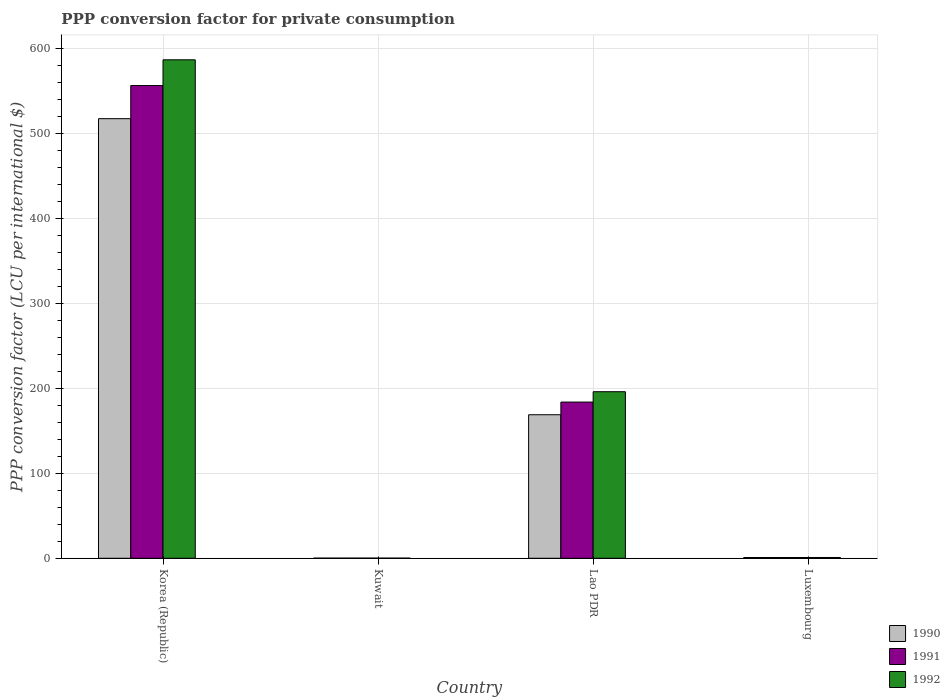How many groups of bars are there?
Your answer should be compact. 4. Are the number of bars per tick equal to the number of legend labels?
Offer a very short reply. Yes. Are the number of bars on each tick of the X-axis equal?
Make the answer very short. Yes. How many bars are there on the 1st tick from the left?
Your answer should be very brief. 3. How many bars are there on the 3rd tick from the right?
Offer a terse response. 3. What is the label of the 2nd group of bars from the left?
Give a very brief answer. Kuwait. In how many cases, is the number of bars for a given country not equal to the number of legend labels?
Offer a terse response. 0. What is the PPP conversion factor for private consumption in 1990 in Kuwait?
Your answer should be very brief. 0.17. Across all countries, what is the maximum PPP conversion factor for private consumption in 1991?
Offer a terse response. 556.12. Across all countries, what is the minimum PPP conversion factor for private consumption in 1991?
Keep it short and to the point. 0.17. In which country was the PPP conversion factor for private consumption in 1990 minimum?
Offer a terse response. Kuwait. What is the total PPP conversion factor for private consumption in 1990 in the graph?
Your response must be concise. 687.06. What is the difference between the PPP conversion factor for private consumption in 1992 in Lao PDR and that in Luxembourg?
Ensure brevity in your answer.  195.03. What is the difference between the PPP conversion factor for private consumption in 1990 in Lao PDR and the PPP conversion factor for private consumption in 1991 in Kuwait?
Offer a very short reply. 168.67. What is the average PPP conversion factor for private consumption in 1991 per country?
Keep it short and to the point. 185.24. What is the difference between the PPP conversion factor for private consumption of/in 1992 and PPP conversion factor for private consumption of/in 1990 in Luxembourg?
Provide a succinct answer. 0.01. In how many countries, is the PPP conversion factor for private consumption in 1991 greater than 580 LCU?
Your response must be concise. 0. What is the ratio of the PPP conversion factor for private consumption in 1991 in Korea (Republic) to that in Lao PDR?
Make the answer very short. 3.03. Is the PPP conversion factor for private consumption in 1991 in Lao PDR less than that in Luxembourg?
Ensure brevity in your answer.  No. Is the difference between the PPP conversion factor for private consumption in 1992 in Kuwait and Lao PDR greater than the difference between the PPP conversion factor for private consumption in 1990 in Kuwait and Lao PDR?
Your answer should be very brief. No. What is the difference between the highest and the second highest PPP conversion factor for private consumption in 1990?
Provide a short and direct response. 167.94. What is the difference between the highest and the lowest PPP conversion factor for private consumption in 1990?
Offer a terse response. 516.98. In how many countries, is the PPP conversion factor for private consumption in 1992 greater than the average PPP conversion factor for private consumption in 1992 taken over all countries?
Provide a succinct answer. 2. What does the 2nd bar from the left in Luxembourg represents?
Provide a succinct answer. 1991. Is it the case that in every country, the sum of the PPP conversion factor for private consumption in 1991 and PPP conversion factor for private consumption in 1990 is greater than the PPP conversion factor for private consumption in 1992?
Offer a terse response. Yes. What is the difference between two consecutive major ticks on the Y-axis?
Your response must be concise. 100. Does the graph contain any zero values?
Give a very brief answer. No. Where does the legend appear in the graph?
Offer a terse response. Bottom right. How are the legend labels stacked?
Provide a succinct answer. Vertical. What is the title of the graph?
Give a very brief answer. PPP conversion factor for private consumption. Does "1978" appear as one of the legend labels in the graph?
Ensure brevity in your answer.  No. What is the label or title of the X-axis?
Ensure brevity in your answer.  Country. What is the label or title of the Y-axis?
Keep it short and to the point. PPP conversion factor (LCU per international $). What is the PPP conversion factor (LCU per international $) of 1990 in Korea (Republic)?
Ensure brevity in your answer.  517.14. What is the PPP conversion factor (LCU per international $) in 1991 in Korea (Republic)?
Keep it short and to the point. 556.12. What is the PPP conversion factor (LCU per international $) of 1992 in Korea (Republic)?
Your answer should be compact. 586.41. What is the PPP conversion factor (LCU per international $) of 1990 in Kuwait?
Provide a succinct answer. 0.17. What is the PPP conversion factor (LCU per international $) of 1991 in Kuwait?
Give a very brief answer. 0.17. What is the PPP conversion factor (LCU per international $) in 1992 in Kuwait?
Your answer should be very brief. 0.17. What is the PPP conversion factor (LCU per international $) of 1990 in Lao PDR?
Give a very brief answer. 168.84. What is the PPP conversion factor (LCU per international $) of 1991 in Lao PDR?
Your response must be concise. 183.76. What is the PPP conversion factor (LCU per international $) in 1992 in Lao PDR?
Your answer should be very brief. 195.95. What is the PPP conversion factor (LCU per international $) in 1990 in Luxembourg?
Keep it short and to the point. 0.9. What is the PPP conversion factor (LCU per international $) in 1991 in Luxembourg?
Give a very brief answer. 0.91. What is the PPP conversion factor (LCU per international $) in 1992 in Luxembourg?
Your response must be concise. 0.92. Across all countries, what is the maximum PPP conversion factor (LCU per international $) of 1990?
Provide a succinct answer. 517.14. Across all countries, what is the maximum PPP conversion factor (LCU per international $) in 1991?
Offer a very short reply. 556.12. Across all countries, what is the maximum PPP conversion factor (LCU per international $) in 1992?
Provide a succinct answer. 586.41. Across all countries, what is the minimum PPP conversion factor (LCU per international $) of 1990?
Make the answer very short. 0.17. Across all countries, what is the minimum PPP conversion factor (LCU per international $) of 1991?
Your answer should be very brief. 0.17. Across all countries, what is the minimum PPP conversion factor (LCU per international $) of 1992?
Offer a terse response. 0.17. What is the total PPP conversion factor (LCU per international $) of 1990 in the graph?
Offer a terse response. 687.06. What is the total PPP conversion factor (LCU per international $) of 1991 in the graph?
Provide a succinct answer. 740.95. What is the total PPP conversion factor (LCU per international $) of 1992 in the graph?
Give a very brief answer. 783.45. What is the difference between the PPP conversion factor (LCU per international $) in 1990 in Korea (Republic) and that in Kuwait?
Provide a succinct answer. 516.98. What is the difference between the PPP conversion factor (LCU per international $) of 1991 in Korea (Republic) and that in Kuwait?
Provide a short and direct response. 555.94. What is the difference between the PPP conversion factor (LCU per international $) in 1992 in Korea (Republic) and that in Kuwait?
Provide a succinct answer. 586.24. What is the difference between the PPP conversion factor (LCU per international $) in 1990 in Korea (Republic) and that in Lao PDR?
Your answer should be compact. 348.3. What is the difference between the PPP conversion factor (LCU per international $) in 1991 in Korea (Republic) and that in Lao PDR?
Your answer should be very brief. 372.36. What is the difference between the PPP conversion factor (LCU per international $) in 1992 in Korea (Republic) and that in Lao PDR?
Offer a very short reply. 390.46. What is the difference between the PPP conversion factor (LCU per international $) of 1990 in Korea (Republic) and that in Luxembourg?
Your answer should be compact. 516.24. What is the difference between the PPP conversion factor (LCU per international $) of 1991 in Korea (Republic) and that in Luxembourg?
Your answer should be compact. 555.21. What is the difference between the PPP conversion factor (LCU per international $) in 1992 in Korea (Republic) and that in Luxembourg?
Ensure brevity in your answer.  585.49. What is the difference between the PPP conversion factor (LCU per international $) in 1990 in Kuwait and that in Lao PDR?
Provide a short and direct response. -168.68. What is the difference between the PPP conversion factor (LCU per international $) in 1991 in Kuwait and that in Lao PDR?
Your answer should be compact. -183.58. What is the difference between the PPP conversion factor (LCU per international $) in 1992 in Kuwait and that in Lao PDR?
Provide a short and direct response. -195.78. What is the difference between the PPP conversion factor (LCU per international $) in 1990 in Kuwait and that in Luxembourg?
Make the answer very short. -0.74. What is the difference between the PPP conversion factor (LCU per international $) in 1991 in Kuwait and that in Luxembourg?
Offer a terse response. -0.73. What is the difference between the PPP conversion factor (LCU per international $) in 1992 in Kuwait and that in Luxembourg?
Give a very brief answer. -0.75. What is the difference between the PPP conversion factor (LCU per international $) in 1990 in Lao PDR and that in Luxembourg?
Provide a short and direct response. 167.94. What is the difference between the PPP conversion factor (LCU per international $) in 1991 in Lao PDR and that in Luxembourg?
Your answer should be compact. 182.85. What is the difference between the PPP conversion factor (LCU per international $) of 1992 in Lao PDR and that in Luxembourg?
Make the answer very short. 195.03. What is the difference between the PPP conversion factor (LCU per international $) in 1990 in Korea (Republic) and the PPP conversion factor (LCU per international $) in 1991 in Kuwait?
Provide a succinct answer. 516.97. What is the difference between the PPP conversion factor (LCU per international $) of 1990 in Korea (Republic) and the PPP conversion factor (LCU per international $) of 1992 in Kuwait?
Offer a very short reply. 516.98. What is the difference between the PPP conversion factor (LCU per international $) of 1991 in Korea (Republic) and the PPP conversion factor (LCU per international $) of 1992 in Kuwait?
Make the answer very short. 555.95. What is the difference between the PPP conversion factor (LCU per international $) of 1990 in Korea (Republic) and the PPP conversion factor (LCU per international $) of 1991 in Lao PDR?
Make the answer very short. 333.39. What is the difference between the PPP conversion factor (LCU per international $) of 1990 in Korea (Republic) and the PPP conversion factor (LCU per international $) of 1992 in Lao PDR?
Your answer should be compact. 321.19. What is the difference between the PPP conversion factor (LCU per international $) of 1991 in Korea (Republic) and the PPP conversion factor (LCU per international $) of 1992 in Lao PDR?
Your response must be concise. 360.17. What is the difference between the PPP conversion factor (LCU per international $) of 1990 in Korea (Republic) and the PPP conversion factor (LCU per international $) of 1991 in Luxembourg?
Provide a short and direct response. 516.24. What is the difference between the PPP conversion factor (LCU per international $) in 1990 in Korea (Republic) and the PPP conversion factor (LCU per international $) in 1992 in Luxembourg?
Your answer should be very brief. 516.22. What is the difference between the PPP conversion factor (LCU per international $) of 1991 in Korea (Republic) and the PPP conversion factor (LCU per international $) of 1992 in Luxembourg?
Offer a terse response. 555.2. What is the difference between the PPP conversion factor (LCU per international $) of 1990 in Kuwait and the PPP conversion factor (LCU per international $) of 1991 in Lao PDR?
Give a very brief answer. -183.59. What is the difference between the PPP conversion factor (LCU per international $) in 1990 in Kuwait and the PPP conversion factor (LCU per international $) in 1992 in Lao PDR?
Your response must be concise. -195.78. What is the difference between the PPP conversion factor (LCU per international $) of 1991 in Kuwait and the PPP conversion factor (LCU per international $) of 1992 in Lao PDR?
Offer a very short reply. -195.78. What is the difference between the PPP conversion factor (LCU per international $) in 1990 in Kuwait and the PPP conversion factor (LCU per international $) in 1991 in Luxembourg?
Make the answer very short. -0.74. What is the difference between the PPP conversion factor (LCU per international $) in 1990 in Kuwait and the PPP conversion factor (LCU per international $) in 1992 in Luxembourg?
Make the answer very short. -0.75. What is the difference between the PPP conversion factor (LCU per international $) in 1991 in Kuwait and the PPP conversion factor (LCU per international $) in 1992 in Luxembourg?
Provide a succinct answer. -0.75. What is the difference between the PPP conversion factor (LCU per international $) of 1990 in Lao PDR and the PPP conversion factor (LCU per international $) of 1991 in Luxembourg?
Keep it short and to the point. 167.94. What is the difference between the PPP conversion factor (LCU per international $) of 1990 in Lao PDR and the PPP conversion factor (LCU per international $) of 1992 in Luxembourg?
Your response must be concise. 167.92. What is the difference between the PPP conversion factor (LCU per international $) in 1991 in Lao PDR and the PPP conversion factor (LCU per international $) in 1992 in Luxembourg?
Make the answer very short. 182.84. What is the average PPP conversion factor (LCU per international $) of 1990 per country?
Your response must be concise. 171.76. What is the average PPP conversion factor (LCU per international $) in 1991 per country?
Your response must be concise. 185.24. What is the average PPP conversion factor (LCU per international $) of 1992 per country?
Ensure brevity in your answer.  195.86. What is the difference between the PPP conversion factor (LCU per international $) of 1990 and PPP conversion factor (LCU per international $) of 1991 in Korea (Republic)?
Your response must be concise. -38.97. What is the difference between the PPP conversion factor (LCU per international $) in 1990 and PPP conversion factor (LCU per international $) in 1992 in Korea (Republic)?
Ensure brevity in your answer.  -69.27. What is the difference between the PPP conversion factor (LCU per international $) in 1991 and PPP conversion factor (LCU per international $) in 1992 in Korea (Republic)?
Your response must be concise. -30.29. What is the difference between the PPP conversion factor (LCU per international $) in 1990 and PPP conversion factor (LCU per international $) in 1991 in Kuwait?
Give a very brief answer. -0.01. What is the difference between the PPP conversion factor (LCU per international $) of 1990 and PPP conversion factor (LCU per international $) of 1992 in Kuwait?
Provide a succinct answer. -0. What is the difference between the PPP conversion factor (LCU per international $) of 1991 and PPP conversion factor (LCU per international $) of 1992 in Kuwait?
Provide a succinct answer. 0.01. What is the difference between the PPP conversion factor (LCU per international $) of 1990 and PPP conversion factor (LCU per international $) of 1991 in Lao PDR?
Your response must be concise. -14.91. What is the difference between the PPP conversion factor (LCU per international $) of 1990 and PPP conversion factor (LCU per international $) of 1992 in Lao PDR?
Your response must be concise. -27.1. What is the difference between the PPP conversion factor (LCU per international $) in 1991 and PPP conversion factor (LCU per international $) in 1992 in Lao PDR?
Provide a short and direct response. -12.19. What is the difference between the PPP conversion factor (LCU per international $) of 1990 and PPP conversion factor (LCU per international $) of 1991 in Luxembourg?
Your answer should be very brief. -0. What is the difference between the PPP conversion factor (LCU per international $) of 1990 and PPP conversion factor (LCU per international $) of 1992 in Luxembourg?
Your answer should be very brief. -0.01. What is the difference between the PPP conversion factor (LCU per international $) in 1991 and PPP conversion factor (LCU per international $) in 1992 in Luxembourg?
Keep it short and to the point. -0.01. What is the ratio of the PPP conversion factor (LCU per international $) of 1990 in Korea (Republic) to that in Kuwait?
Provide a short and direct response. 3133.39. What is the ratio of the PPP conversion factor (LCU per international $) in 1991 in Korea (Republic) to that in Kuwait?
Ensure brevity in your answer.  3220.52. What is the ratio of the PPP conversion factor (LCU per international $) of 1992 in Korea (Republic) to that in Kuwait?
Give a very brief answer. 3518. What is the ratio of the PPP conversion factor (LCU per international $) of 1990 in Korea (Republic) to that in Lao PDR?
Make the answer very short. 3.06. What is the ratio of the PPP conversion factor (LCU per international $) of 1991 in Korea (Republic) to that in Lao PDR?
Your response must be concise. 3.03. What is the ratio of the PPP conversion factor (LCU per international $) in 1992 in Korea (Republic) to that in Lao PDR?
Your answer should be compact. 2.99. What is the ratio of the PPP conversion factor (LCU per international $) of 1990 in Korea (Republic) to that in Luxembourg?
Offer a very short reply. 571.61. What is the ratio of the PPP conversion factor (LCU per international $) of 1991 in Korea (Republic) to that in Luxembourg?
Provide a succinct answer. 614.18. What is the ratio of the PPP conversion factor (LCU per international $) of 1992 in Korea (Republic) to that in Luxembourg?
Provide a short and direct response. 637.73. What is the ratio of the PPP conversion factor (LCU per international $) in 1991 in Kuwait to that in Lao PDR?
Ensure brevity in your answer.  0. What is the ratio of the PPP conversion factor (LCU per international $) in 1992 in Kuwait to that in Lao PDR?
Make the answer very short. 0. What is the ratio of the PPP conversion factor (LCU per international $) of 1990 in Kuwait to that in Luxembourg?
Make the answer very short. 0.18. What is the ratio of the PPP conversion factor (LCU per international $) of 1991 in Kuwait to that in Luxembourg?
Your answer should be compact. 0.19. What is the ratio of the PPP conversion factor (LCU per international $) of 1992 in Kuwait to that in Luxembourg?
Give a very brief answer. 0.18. What is the ratio of the PPP conversion factor (LCU per international $) in 1990 in Lao PDR to that in Luxembourg?
Your response must be concise. 186.63. What is the ratio of the PPP conversion factor (LCU per international $) of 1991 in Lao PDR to that in Luxembourg?
Make the answer very short. 202.94. What is the ratio of the PPP conversion factor (LCU per international $) of 1992 in Lao PDR to that in Luxembourg?
Your response must be concise. 213.1. What is the difference between the highest and the second highest PPP conversion factor (LCU per international $) in 1990?
Give a very brief answer. 348.3. What is the difference between the highest and the second highest PPP conversion factor (LCU per international $) of 1991?
Provide a short and direct response. 372.36. What is the difference between the highest and the second highest PPP conversion factor (LCU per international $) in 1992?
Offer a terse response. 390.46. What is the difference between the highest and the lowest PPP conversion factor (LCU per international $) of 1990?
Offer a very short reply. 516.98. What is the difference between the highest and the lowest PPP conversion factor (LCU per international $) of 1991?
Your answer should be very brief. 555.94. What is the difference between the highest and the lowest PPP conversion factor (LCU per international $) in 1992?
Provide a succinct answer. 586.24. 